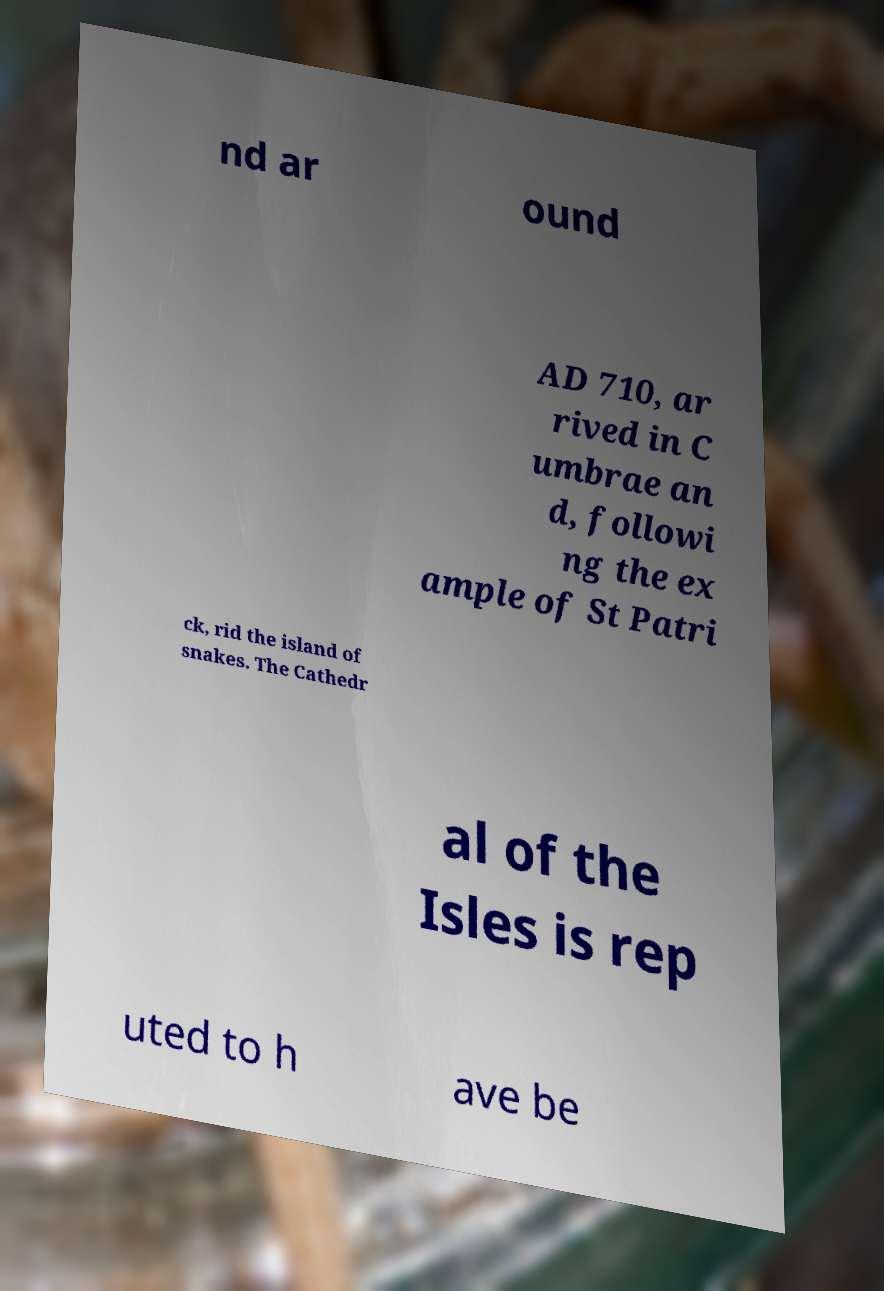What messages or text are displayed in this image? I need them in a readable, typed format. nd ar ound AD 710, ar rived in C umbrae an d, followi ng the ex ample of St Patri ck, rid the island of snakes. The Cathedr al of the Isles is rep uted to h ave be 